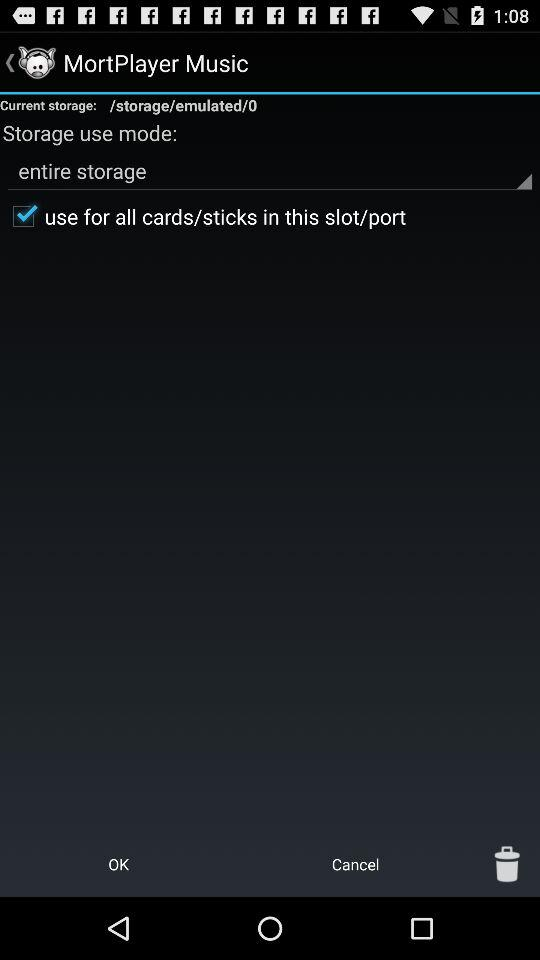What is the name of the application? The name of the application is "MortPlayer Music". 